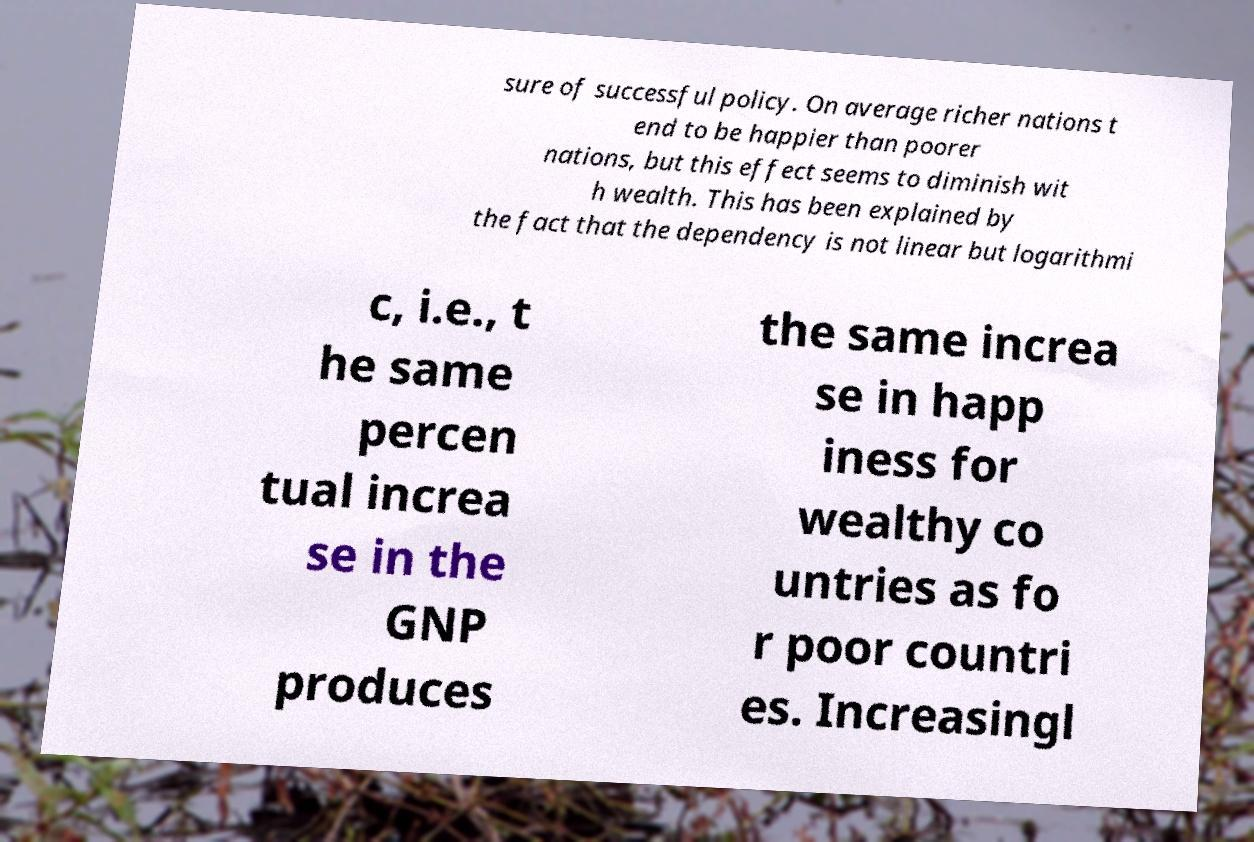Could you extract and type out the text from this image? sure of successful policy. On average richer nations t end to be happier than poorer nations, but this effect seems to diminish wit h wealth. This has been explained by the fact that the dependency is not linear but logarithmi c, i.e., t he same percen tual increa se in the GNP produces the same increa se in happ iness for wealthy co untries as fo r poor countri es. Increasingl 